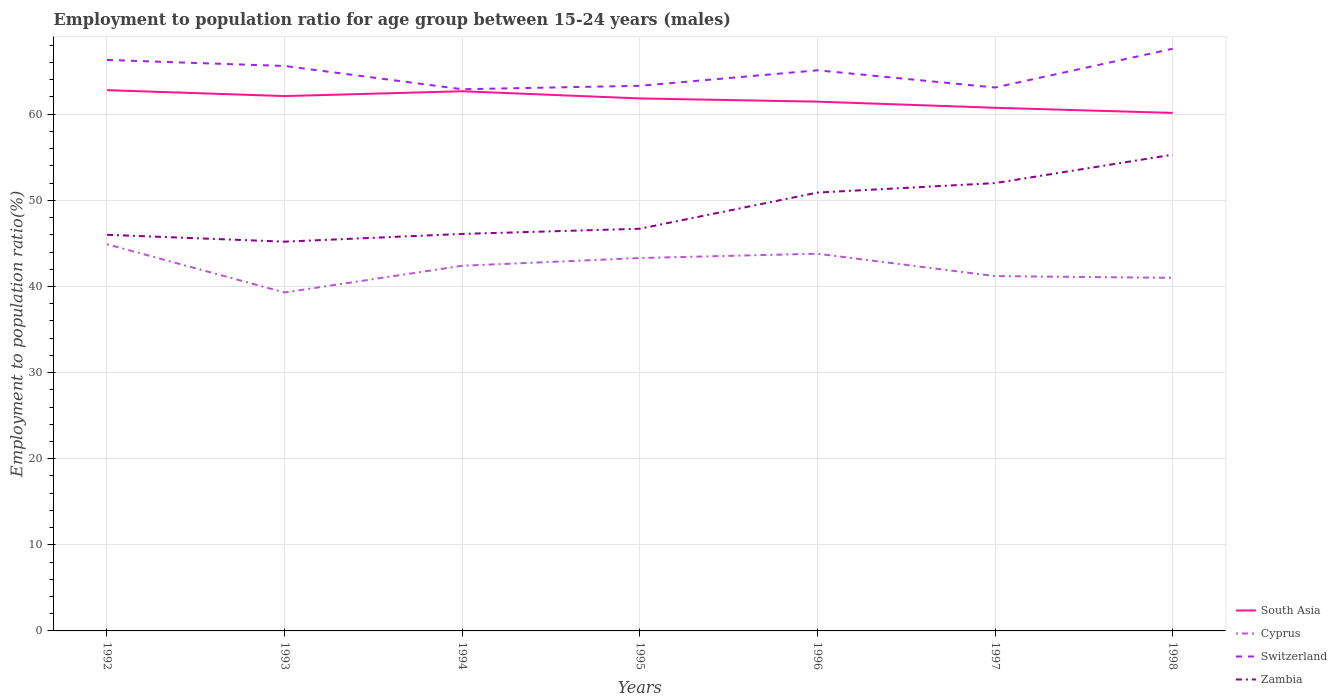Is the number of lines equal to the number of legend labels?
Provide a succinct answer. Yes. Across all years, what is the maximum employment to population ratio in Switzerland?
Give a very brief answer. 62.9. In which year was the employment to population ratio in Switzerland maximum?
Provide a short and direct response. 1994. What is the total employment to population ratio in Switzerland in the graph?
Keep it short and to the point. 2.3. What is the difference between the highest and the second highest employment to population ratio in Switzerland?
Your response must be concise. 4.7. What is the difference between the highest and the lowest employment to population ratio in Switzerland?
Give a very brief answer. 4. Does the graph contain grids?
Provide a succinct answer. Yes. How are the legend labels stacked?
Your answer should be very brief. Vertical. What is the title of the graph?
Your answer should be compact. Employment to population ratio for age group between 15-24 years (males). What is the label or title of the X-axis?
Provide a succinct answer. Years. What is the Employment to population ratio(%) in South Asia in 1992?
Provide a short and direct response. 62.79. What is the Employment to population ratio(%) in Cyprus in 1992?
Offer a terse response. 44.9. What is the Employment to population ratio(%) of Switzerland in 1992?
Keep it short and to the point. 66.3. What is the Employment to population ratio(%) of South Asia in 1993?
Offer a very short reply. 62.11. What is the Employment to population ratio(%) in Cyprus in 1993?
Offer a very short reply. 39.3. What is the Employment to population ratio(%) in Switzerland in 1993?
Provide a short and direct response. 65.6. What is the Employment to population ratio(%) of Zambia in 1993?
Give a very brief answer. 45.2. What is the Employment to population ratio(%) in South Asia in 1994?
Give a very brief answer. 62.67. What is the Employment to population ratio(%) in Cyprus in 1994?
Make the answer very short. 42.4. What is the Employment to population ratio(%) in Switzerland in 1994?
Your answer should be compact. 62.9. What is the Employment to population ratio(%) of Zambia in 1994?
Your response must be concise. 46.1. What is the Employment to population ratio(%) in South Asia in 1995?
Provide a succinct answer. 61.83. What is the Employment to population ratio(%) of Cyprus in 1995?
Make the answer very short. 43.3. What is the Employment to population ratio(%) of Switzerland in 1995?
Keep it short and to the point. 63.3. What is the Employment to population ratio(%) of Zambia in 1995?
Your answer should be very brief. 46.7. What is the Employment to population ratio(%) of South Asia in 1996?
Your answer should be very brief. 61.46. What is the Employment to population ratio(%) in Cyprus in 1996?
Your response must be concise. 43.8. What is the Employment to population ratio(%) in Switzerland in 1996?
Offer a very short reply. 65.1. What is the Employment to population ratio(%) in Zambia in 1996?
Provide a short and direct response. 50.9. What is the Employment to population ratio(%) of South Asia in 1997?
Give a very brief answer. 60.75. What is the Employment to population ratio(%) in Cyprus in 1997?
Your response must be concise. 41.2. What is the Employment to population ratio(%) in Switzerland in 1997?
Offer a terse response. 63.1. What is the Employment to population ratio(%) in South Asia in 1998?
Make the answer very short. 60.15. What is the Employment to population ratio(%) of Cyprus in 1998?
Make the answer very short. 41. What is the Employment to population ratio(%) in Switzerland in 1998?
Offer a very short reply. 67.6. What is the Employment to population ratio(%) in Zambia in 1998?
Make the answer very short. 55.3. Across all years, what is the maximum Employment to population ratio(%) in South Asia?
Provide a succinct answer. 62.79. Across all years, what is the maximum Employment to population ratio(%) in Cyprus?
Provide a succinct answer. 44.9. Across all years, what is the maximum Employment to population ratio(%) of Switzerland?
Your answer should be very brief. 67.6. Across all years, what is the maximum Employment to population ratio(%) of Zambia?
Give a very brief answer. 55.3. Across all years, what is the minimum Employment to population ratio(%) of South Asia?
Ensure brevity in your answer.  60.15. Across all years, what is the minimum Employment to population ratio(%) of Cyprus?
Your answer should be compact. 39.3. Across all years, what is the minimum Employment to population ratio(%) in Switzerland?
Make the answer very short. 62.9. Across all years, what is the minimum Employment to population ratio(%) of Zambia?
Your answer should be very brief. 45.2. What is the total Employment to population ratio(%) in South Asia in the graph?
Offer a very short reply. 431.75. What is the total Employment to population ratio(%) of Cyprus in the graph?
Provide a succinct answer. 295.9. What is the total Employment to population ratio(%) in Switzerland in the graph?
Your answer should be very brief. 453.9. What is the total Employment to population ratio(%) in Zambia in the graph?
Your response must be concise. 342.2. What is the difference between the Employment to population ratio(%) of South Asia in 1992 and that in 1993?
Keep it short and to the point. 0.69. What is the difference between the Employment to population ratio(%) of Cyprus in 1992 and that in 1993?
Make the answer very short. 5.6. What is the difference between the Employment to population ratio(%) in Zambia in 1992 and that in 1993?
Provide a succinct answer. 0.8. What is the difference between the Employment to population ratio(%) in South Asia in 1992 and that in 1994?
Offer a terse response. 0.13. What is the difference between the Employment to population ratio(%) in South Asia in 1992 and that in 1995?
Provide a succinct answer. 0.96. What is the difference between the Employment to population ratio(%) of Cyprus in 1992 and that in 1995?
Make the answer very short. 1.6. What is the difference between the Employment to population ratio(%) in South Asia in 1992 and that in 1996?
Provide a short and direct response. 1.33. What is the difference between the Employment to population ratio(%) of Zambia in 1992 and that in 1996?
Offer a very short reply. -4.9. What is the difference between the Employment to population ratio(%) of South Asia in 1992 and that in 1997?
Ensure brevity in your answer.  2.05. What is the difference between the Employment to population ratio(%) in Cyprus in 1992 and that in 1997?
Your answer should be compact. 3.7. What is the difference between the Employment to population ratio(%) in Switzerland in 1992 and that in 1997?
Offer a terse response. 3.2. What is the difference between the Employment to population ratio(%) in Zambia in 1992 and that in 1997?
Your answer should be very brief. -6. What is the difference between the Employment to population ratio(%) of South Asia in 1992 and that in 1998?
Offer a terse response. 2.65. What is the difference between the Employment to population ratio(%) in Switzerland in 1992 and that in 1998?
Offer a very short reply. -1.3. What is the difference between the Employment to population ratio(%) in South Asia in 1993 and that in 1994?
Keep it short and to the point. -0.56. What is the difference between the Employment to population ratio(%) of Cyprus in 1993 and that in 1994?
Make the answer very short. -3.1. What is the difference between the Employment to population ratio(%) in Switzerland in 1993 and that in 1994?
Provide a succinct answer. 2.7. What is the difference between the Employment to population ratio(%) in Zambia in 1993 and that in 1994?
Offer a terse response. -0.9. What is the difference between the Employment to population ratio(%) in South Asia in 1993 and that in 1995?
Your answer should be very brief. 0.27. What is the difference between the Employment to population ratio(%) of South Asia in 1993 and that in 1996?
Your answer should be compact. 0.65. What is the difference between the Employment to population ratio(%) of South Asia in 1993 and that in 1997?
Offer a very short reply. 1.36. What is the difference between the Employment to population ratio(%) of Cyprus in 1993 and that in 1997?
Give a very brief answer. -1.9. What is the difference between the Employment to population ratio(%) of Zambia in 1993 and that in 1997?
Ensure brevity in your answer.  -6.8. What is the difference between the Employment to population ratio(%) of South Asia in 1993 and that in 1998?
Your answer should be very brief. 1.96. What is the difference between the Employment to population ratio(%) in Cyprus in 1993 and that in 1998?
Provide a short and direct response. -1.7. What is the difference between the Employment to population ratio(%) of South Asia in 1994 and that in 1995?
Offer a terse response. 0.84. What is the difference between the Employment to population ratio(%) in South Asia in 1994 and that in 1996?
Provide a short and direct response. 1.21. What is the difference between the Employment to population ratio(%) of Zambia in 1994 and that in 1996?
Your answer should be very brief. -4.8. What is the difference between the Employment to population ratio(%) of South Asia in 1994 and that in 1997?
Give a very brief answer. 1.92. What is the difference between the Employment to population ratio(%) of Cyprus in 1994 and that in 1997?
Your response must be concise. 1.2. What is the difference between the Employment to population ratio(%) of Switzerland in 1994 and that in 1997?
Offer a terse response. -0.2. What is the difference between the Employment to population ratio(%) in South Asia in 1994 and that in 1998?
Ensure brevity in your answer.  2.52. What is the difference between the Employment to population ratio(%) in Zambia in 1994 and that in 1998?
Your answer should be compact. -9.2. What is the difference between the Employment to population ratio(%) of South Asia in 1995 and that in 1996?
Your answer should be very brief. 0.37. What is the difference between the Employment to population ratio(%) in Switzerland in 1995 and that in 1996?
Keep it short and to the point. -1.8. What is the difference between the Employment to population ratio(%) in Zambia in 1995 and that in 1996?
Give a very brief answer. -4.2. What is the difference between the Employment to population ratio(%) in South Asia in 1995 and that in 1997?
Provide a short and direct response. 1.08. What is the difference between the Employment to population ratio(%) of Cyprus in 1995 and that in 1997?
Give a very brief answer. 2.1. What is the difference between the Employment to population ratio(%) in Switzerland in 1995 and that in 1997?
Offer a terse response. 0.2. What is the difference between the Employment to population ratio(%) of Zambia in 1995 and that in 1997?
Provide a short and direct response. -5.3. What is the difference between the Employment to population ratio(%) in South Asia in 1995 and that in 1998?
Your response must be concise. 1.68. What is the difference between the Employment to population ratio(%) in Switzerland in 1995 and that in 1998?
Ensure brevity in your answer.  -4.3. What is the difference between the Employment to population ratio(%) of Zambia in 1995 and that in 1998?
Keep it short and to the point. -8.6. What is the difference between the Employment to population ratio(%) of South Asia in 1996 and that in 1997?
Make the answer very short. 0.71. What is the difference between the Employment to population ratio(%) of Cyprus in 1996 and that in 1997?
Make the answer very short. 2.6. What is the difference between the Employment to population ratio(%) of Zambia in 1996 and that in 1997?
Your answer should be compact. -1.1. What is the difference between the Employment to population ratio(%) of South Asia in 1996 and that in 1998?
Keep it short and to the point. 1.31. What is the difference between the Employment to population ratio(%) in Switzerland in 1996 and that in 1998?
Your response must be concise. -2.5. What is the difference between the Employment to population ratio(%) in Zambia in 1996 and that in 1998?
Offer a very short reply. -4.4. What is the difference between the Employment to population ratio(%) in South Asia in 1997 and that in 1998?
Provide a succinct answer. 0.6. What is the difference between the Employment to population ratio(%) of Switzerland in 1997 and that in 1998?
Provide a short and direct response. -4.5. What is the difference between the Employment to population ratio(%) in South Asia in 1992 and the Employment to population ratio(%) in Cyprus in 1993?
Make the answer very short. 23.49. What is the difference between the Employment to population ratio(%) in South Asia in 1992 and the Employment to population ratio(%) in Switzerland in 1993?
Offer a very short reply. -2.81. What is the difference between the Employment to population ratio(%) of South Asia in 1992 and the Employment to population ratio(%) of Zambia in 1993?
Your answer should be very brief. 17.59. What is the difference between the Employment to population ratio(%) of Cyprus in 1992 and the Employment to population ratio(%) of Switzerland in 1993?
Give a very brief answer. -20.7. What is the difference between the Employment to population ratio(%) of Switzerland in 1992 and the Employment to population ratio(%) of Zambia in 1993?
Offer a very short reply. 21.1. What is the difference between the Employment to population ratio(%) of South Asia in 1992 and the Employment to population ratio(%) of Cyprus in 1994?
Provide a succinct answer. 20.39. What is the difference between the Employment to population ratio(%) of South Asia in 1992 and the Employment to population ratio(%) of Switzerland in 1994?
Make the answer very short. -0.11. What is the difference between the Employment to population ratio(%) in South Asia in 1992 and the Employment to population ratio(%) in Zambia in 1994?
Your response must be concise. 16.69. What is the difference between the Employment to population ratio(%) of Cyprus in 1992 and the Employment to population ratio(%) of Switzerland in 1994?
Make the answer very short. -18. What is the difference between the Employment to population ratio(%) in Switzerland in 1992 and the Employment to population ratio(%) in Zambia in 1994?
Offer a very short reply. 20.2. What is the difference between the Employment to population ratio(%) in South Asia in 1992 and the Employment to population ratio(%) in Cyprus in 1995?
Your answer should be compact. 19.49. What is the difference between the Employment to population ratio(%) of South Asia in 1992 and the Employment to population ratio(%) of Switzerland in 1995?
Provide a short and direct response. -0.51. What is the difference between the Employment to population ratio(%) in South Asia in 1992 and the Employment to population ratio(%) in Zambia in 1995?
Offer a terse response. 16.09. What is the difference between the Employment to population ratio(%) of Cyprus in 1992 and the Employment to population ratio(%) of Switzerland in 1995?
Provide a short and direct response. -18.4. What is the difference between the Employment to population ratio(%) in Switzerland in 1992 and the Employment to population ratio(%) in Zambia in 1995?
Provide a short and direct response. 19.6. What is the difference between the Employment to population ratio(%) of South Asia in 1992 and the Employment to population ratio(%) of Cyprus in 1996?
Give a very brief answer. 18.99. What is the difference between the Employment to population ratio(%) in South Asia in 1992 and the Employment to population ratio(%) in Switzerland in 1996?
Your response must be concise. -2.31. What is the difference between the Employment to population ratio(%) of South Asia in 1992 and the Employment to population ratio(%) of Zambia in 1996?
Give a very brief answer. 11.89. What is the difference between the Employment to population ratio(%) of Cyprus in 1992 and the Employment to population ratio(%) of Switzerland in 1996?
Keep it short and to the point. -20.2. What is the difference between the Employment to population ratio(%) of South Asia in 1992 and the Employment to population ratio(%) of Cyprus in 1997?
Provide a short and direct response. 21.59. What is the difference between the Employment to population ratio(%) in South Asia in 1992 and the Employment to population ratio(%) in Switzerland in 1997?
Ensure brevity in your answer.  -0.31. What is the difference between the Employment to population ratio(%) of South Asia in 1992 and the Employment to population ratio(%) of Zambia in 1997?
Provide a succinct answer. 10.79. What is the difference between the Employment to population ratio(%) in Cyprus in 1992 and the Employment to population ratio(%) in Switzerland in 1997?
Your answer should be very brief. -18.2. What is the difference between the Employment to population ratio(%) in Cyprus in 1992 and the Employment to population ratio(%) in Zambia in 1997?
Provide a succinct answer. -7.1. What is the difference between the Employment to population ratio(%) of South Asia in 1992 and the Employment to population ratio(%) of Cyprus in 1998?
Your response must be concise. 21.79. What is the difference between the Employment to population ratio(%) of South Asia in 1992 and the Employment to population ratio(%) of Switzerland in 1998?
Ensure brevity in your answer.  -4.81. What is the difference between the Employment to population ratio(%) in South Asia in 1992 and the Employment to population ratio(%) in Zambia in 1998?
Offer a very short reply. 7.49. What is the difference between the Employment to population ratio(%) in Cyprus in 1992 and the Employment to population ratio(%) in Switzerland in 1998?
Give a very brief answer. -22.7. What is the difference between the Employment to population ratio(%) in Cyprus in 1992 and the Employment to population ratio(%) in Zambia in 1998?
Provide a succinct answer. -10.4. What is the difference between the Employment to population ratio(%) in Switzerland in 1992 and the Employment to population ratio(%) in Zambia in 1998?
Keep it short and to the point. 11. What is the difference between the Employment to population ratio(%) in South Asia in 1993 and the Employment to population ratio(%) in Cyprus in 1994?
Your answer should be compact. 19.71. What is the difference between the Employment to population ratio(%) in South Asia in 1993 and the Employment to population ratio(%) in Switzerland in 1994?
Your response must be concise. -0.79. What is the difference between the Employment to population ratio(%) of South Asia in 1993 and the Employment to population ratio(%) of Zambia in 1994?
Provide a short and direct response. 16.01. What is the difference between the Employment to population ratio(%) of Cyprus in 1993 and the Employment to population ratio(%) of Switzerland in 1994?
Offer a terse response. -23.6. What is the difference between the Employment to population ratio(%) of South Asia in 1993 and the Employment to population ratio(%) of Cyprus in 1995?
Provide a succinct answer. 18.81. What is the difference between the Employment to population ratio(%) in South Asia in 1993 and the Employment to population ratio(%) in Switzerland in 1995?
Make the answer very short. -1.19. What is the difference between the Employment to population ratio(%) in South Asia in 1993 and the Employment to population ratio(%) in Zambia in 1995?
Make the answer very short. 15.41. What is the difference between the Employment to population ratio(%) in Cyprus in 1993 and the Employment to population ratio(%) in Zambia in 1995?
Provide a short and direct response. -7.4. What is the difference between the Employment to population ratio(%) of South Asia in 1993 and the Employment to population ratio(%) of Cyprus in 1996?
Your answer should be very brief. 18.31. What is the difference between the Employment to population ratio(%) in South Asia in 1993 and the Employment to population ratio(%) in Switzerland in 1996?
Your response must be concise. -2.99. What is the difference between the Employment to population ratio(%) of South Asia in 1993 and the Employment to population ratio(%) of Zambia in 1996?
Provide a succinct answer. 11.21. What is the difference between the Employment to population ratio(%) of Cyprus in 1993 and the Employment to population ratio(%) of Switzerland in 1996?
Give a very brief answer. -25.8. What is the difference between the Employment to population ratio(%) of Cyprus in 1993 and the Employment to population ratio(%) of Zambia in 1996?
Provide a succinct answer. -11.6. What is the difference between the Employment to population ratio(%) in South Asia in 1993 and the Employment to population ratio(%) in Cyprus in 1997?
Provide a succinct answer. 20.91. What is the difference between the Employment to population ratio(%) in South Asia in 1993 and the Employment to population ratio(%) in Switzerland in 1997?
Provide a short and direct response. -0.99. What is the difference between the Employment to population ratio(%) in South Asia in 1993 and the Employment to population ratio(%) in Zambia in 1997?
Provide a succinct answer. 10.11. What is the difference between the Employment to population ratio(%) in Cyprus in 1993 and the Employment to population ratio(%) in Switzerland in 1997?
Your answer should be very brief. -23.8. What is the difference between the Employment to population ratio(%) in Switzerland in 1993 and the Employment to population ratio(%) in Zambia in 1997?
Give a very brief answer. 13.6. What is the difference between the Employment to population ratio(%) in South Asia in 1993 and the Employment to population ratio(%) in Cyprus in 1998?
Your answer should be compact. 21.11. What is the difference between the Employment to population ratio(%) in South Asia in 1993 and the Employment to population ratio(%) in Switzerland in 1998?
Your answer should be compact. -5.49. What is the difference between the Employment to population ratio(%) in South Asia in 1993 and the Employment to population ratio(%) in Zambia in 1998?
Your answer should be very brief. 6.81. What is the difference between the Employment to population ratio(%) of Cyprus in 1993 and the Employment to population ratio(%) of Switzerland in 1998?
Provide a succinct answer. -28.3. What is the difference between the Employment to population ratio(%) in Cyprus in 1993 and the Employment to population ratio(%) in Zambia in 1998?
Provide a short and direct response. -16. What is the difference between the Employment to population ratio(%) in Switzerland in 1993 and the Employment to population ratio(%) in Zambia in 1998?
Keep it short and to the point. 10.3. What is the difference between the Employment to population ratio(%) of South Asia in 1994 and the Employment to population ratio(%) of Cyprus in 1995?
Provide a short and direct response. 19.37. What is the difference between the Employment to population ratio(%) in South Asia in 1994 and the Employment to population ratio(%) in Switzerland in 1995?
Keep it short and to the point. -0.63. What is the difference between the Employment to population ratio(%) of South Asia in 1994 and the Employment to population ratio(%) of Zambia in 1995?
Your answer should be compact. 15.97. What is the difference between the Employment to population ratio(%) in Cyprus in 1994 and the Employment to population ratio(%) in Switzerland in 1995?
Make the answer very short. -20.9. What is the difference between the Employment to population ratio(%) of Switzerland in 1994 and the Employment to population ratio(%) of Zambia in 1995?
Ensure brevity in your answer.  16.2. What is the difference between the Employment to population ratio(%) in South Asia in 1994 and the Employment to population ratio(%) in Cyprus in 1996?
Your answer should be compact. 18.87. What is the difference between the Employment to population ratio(%) of South Asia in 1994 and the Employment to population ratio(%) of Switzerland in 1996?
Provide a succinct answer. -2.43. What is the difference between the Employment to population ratio(%) in South Asia in 1994 and the Employment to population ratio(%) in Zambia in 1996?
Your response must be concise. 11.77. What is the difference between the Employment to population ratio(%) of Cyprus in 1994 and the Employment to population ratio(%) of Switzerland in 1996?
Provide a succinct answer. -22.7. What is the difference between the Employment to population ratio(%) in Switzerland in 1994 and the Employment to population ratio(%) in Zambia in 1996?
Your answer should be compact. 12. What is the difference between the Employment to population ratio(%) in South Asia in 1994 and the Employment to population ratio(%) in Cyprus in 1997?
Your answer should be very brief. 21.47. What is the difference between the Employment to population ratio(%) of South Asia in 1994 and the Employment to population ratio(%) of Switzerland in 1997?
Your response must be concise. -0.43. What is the difference between the Employment to population ratio(%) of South Asia in 1994 and the Employment to population ratio(%) of Zambia in 1997?
Offer a very short reply. 10.67. What is the difference between the Employment to population ratio(%) of Cyprus in 1994 and the Employment to population ratio(%) of Switzerland in 1997?
Give a very brief answer. -20.7. What is the difference between the Employment to population ratio(%) of Switzerland in 1994 and the Employment to population ratio(%) of Zambia in 1997?
Your response must be concise. 10.9. What is the difference between the Employment to population ratio(%) in South Asia in 1994 and the Employment to population ratio(%) in Cyprus in 1998?
Make the answer very short. 21.67. What is the difference between the Employment to population ratio(%) in South Asia in 1994 and the Employment to population ratio(%) in Switzerland in 1998?
Provide a short and direct response. -4.93. What is the difference between the Employment to population ratio(%) of South Asia in 1994 and the Employment to population ratio(%) of Zambia in 1998?
Provide a succinct answer. 7.37. What is the difference between the Employment to population ratio(%) of Cyprus in 1994 and the Employment to population ratio(%) of Switzerland in 1998?
Your response must be concise. -25.2. What is the difference between the Employment to population ratio(%) of Cyprus in 1994 and the Employment to population ratio(%) of Zambia in 1998?
Offer a terse response. -12.9. What is the difference between the Employment to population ratio(%) of South Asia in 1995 and the Employment to population ratio(%) of Cyprus in 1996?
Your answer should be very brief. 18.03. What is the difference between the Employment to population ratio(%) of South Asia in 1995 and the Employment to population ratio(%) of Switzerland in 1996?
Offer a terse response. -3.27. What is the difference between the Employment to population ratio(%) in South Asia in 1995 and the Employment to population ratio(%) in Zambia in 1996?
Make the answer very short. 10.93. What is the difference between the Employment to population ratio(%) in Cyprus in 1995 and the Employment to population ratio(%) in Switzerland in 1996?
Your response must be concise. -21.8. What is the difference between the Employment to population ratio(%) in Switzerland in 1995 and the Employment to population ratio(%) in Zambia in 1996?
Your answer should be compact. 12.4. What is the difference between the Employment to population ratio(%) of South Asia in 1995 and the Employment to population ratio(%) of Cyprus in 1997?
Provide a succinct answer. 20.63. What is the difference between the Employment to population ratio(%) of South Asia in 1995 and the Employment to population ratio(%) of Switzerland in 1997?
Your answer should be compact. -1.27. What is the difference between the Employment to population ratio(%) in South Asia in 1995 and the Employment to population ratio(%) in Zambia in 1997?
Provide a succinct answer. 9.83. What is the difference between the Employment to population ratio(%) in Cyprus in 1995 and the Employment to population ratio(%) in Switzerland in 1997?
Give a very brief answer. -19.8. What is the difference between the Employment to population ratio(%) of Cyprus in 1995 and the Employment to population ratio(%) of Zambia in 1997?
Keep it short and to the point. -8.7. What is the difference between the Employment to population ratio(%) in Switzerland in 1995 and the Employment to population ratio(%) in Zambia in 1997?
Keep it short and to the point. 11.3. What is the difference between the Employment to population ratio(%) in South Asia in 1995 and the Employment to population ratio(%) in Cyprus in 1998?
Make the answer very short. 20.83. What is the difference between the Employment to population ratio(%) in South Asia in 1995 and the Employment to population ratio(%) in Switzerland in 1998?
Keep it short and to the point. -5.77. What is the difference between the Employment to population ratio(%) of South Asia in 1995 and the Employment to population ratio(%) of Zambia in 1998?
Keep it short and to the point. 6.53. What is the difference between the Employment to population ratio(%) of Cyprus in 1995 and the Employment to population ratio(%) of Switzerland in 1998?
Make the answer very short. -24.3. What is the difference between the Employment to population ratio(%) in Switzerland in 1995 and the Employment to population ratio(%) in Zambia in 1998?
Your answer should be very brief. 8. What is the difference between the Employment to population ratio(%) of South Asia in 1996 and the Employment to population ratio(%) of Cyprus in 1997?
Your response must be concise. 20.26. What is the difference between the Employment to population ratio(%) in South Asia in 1996 and the Employment to population ratio(%) in Switzerland in 1997?
Keep it short and to the point. -1.64. What is the difference between the Employment to population ratio(%) in South Asia in 1996 and the Employment to population ratio(%) in Zambia in 1997?
Make the answer very short. 9.46. What is the difference between the Employment to population ratio(%) in Cyprus in 1996 and the Employment to population ratio(%) in Switzerland in 1997?
Provide a short and direct response. -19.3. What is the difference between the Employment to population ratio(%) of Switzerland in 1996 and the Employment to population ratio(%) of Zambia in 1997?
Ensure brevity in your answer.  13.1. What is the difference between the Employment to population ratio(%) in South Asia in 1996 and the Employment to population ratio(%) in Cyprus in 1998?
Offer a terse response. 20.46. What is the difference between the Employment to population ratio(%) in South Asia in 1996 and the Employment to population ratio(%) in Switzerland in 1998?
Provide a succinct answer. -6.14. What is the difference between the Employment to population ratio(%) in South Asia in 1996 and the Employment to population ratio(%) in Zambia in 1998?
Ensure brevity in your answer.  6.16. What is the difference between the Employment to population ratio(%) in Cyprus in 1996 and the Employment to population ratio(%) in Switzerland in 1998?
Give a very brief answer. -23.8. What is the difference between the Employment to population ratio(%) in Switzerland in 1996 and the Employment to population ratio(%) in Zambia in 1998?
Your answer should be compact. 9.8. What is the difference between the Employment to population ratio(%) of South Asia in 1997 and the Employment to population ratio(%) of Cyprus in 1998?
Your response must be concise. 19.75. What is the difference between the Employment to population ratio(%) in South Asia in 1997 and the Employment to population ratio(%) in Switzerland in 1998?
Make the answer very short. -6.85. What is the difference between the Employment to population ratio(%) of South Asia in 1997 and the Employment to population ratio(%) of Zambia in 1998?
Make the answer very short. 5.45. What is the difference between the Employment to population ratio(%) of Cyprus in 1997 and the Employment to population ratio(%) of Switzerland in 1998?
Your answer should be compact. -26.4. What is the difference between the Employment to population ratio(%) in Cyprus in 1997 and the Employment to population ratio(%) in Zambia in 1998?
Your answer should be very brief. -14.1. What is the average Employment to population ratio(%) of South Asia per year?
Offer a terse response. 61.68. What is the average Employment to population ratio(%) in Cyprus per year?
Give a very brief answer. 42.27. What is the average Employment to population ratio(%) of Switzerland per year?
Provide a succinct answer. 64.84. What is the average Employment to population ratio(%) in Zambia per year?
Provide a succinct answer. 48.89. In the year 1992, what is the difference between the Employment to population ratio(%) of South Asia and Employment to population ratio(%) of Cyprus?
Provide a succinct answer. 17.89. In the year 1992, what is the difference between the Employment to population ratio(%) of South Asia and Employment to population ratio(%) of Switzerland?
Your answer should be very brief. -3.51. In the year 1992, what is the difference between the Employment to population ratio(%) in South Asia and Employment to population ratio(%) in Zambia?
Make the answer very short. 16.79. In the year 1992, what is the difference between the Employment to population ratio(%) of Cyprus and Employment to population ratio(%) of Switzerland?
Offer a terse response. -21.4. In the year 1992, what is the difference between the Employment to population ratio(%) of Cyprus and Employment to population ratio(%) of Zambia?
Ensure brevity in your answer.  -1.1. In the year 1992, what is the difference between the Employment to population ratio(%) in Switzerland and Employment to population ratio(%) in Zambia?
Make the answer very short. 20.3. In the year 1993, what is the difference between the Employment to population ratio(%) of South Asia and Employment to population ratio(%) of Cyprus?
Keep it short and to the point. 22.81. In the year 1993, what is the difference between the Employment to population ratio(%) in South Asia and Employment to population ratio(%) in Switzerland?
Make the answer very short. -3.49. In the year 1993, what is the difference between the Employment to population ratio(%) of South Asia and Employment to population ratio(%) of Zambia?
Ensure brevity in your answer.  16.91. In the year 1993, what is the difference between the Employment to population ratio(%) in Cyprus and Employment to population ratio(%) in Switzerland?
Your answer should be compact. -26.3. In the year 1993, what is the difference between the Employment to population ratio(%) in Cyprus and Employment to population ratio(%) in Zambia?
Your answer should be very brief. -5.9. In the year 1993, what is the difference between the Employment to population ratio(%) in Switzerland and Employment to population ratio(%) in Zambia?
Provide a succinct answer. 20.4. In the year 1994, what is the difference between the Employment to population ratio(%) of South Asia and Employment to population ratio(%) of Cyprus?
Provide a succinct answer. 20.27. In the year 1994, what is the difference between the Employment to population ratio(%) of South Asia and Employment to population ratio(%) of Switzerland?
Give a very brief answer. -0.23. In the year 1994, what is the difference between the Employment to population ratio(%) in South Asia and Employment to population ratio(%) in Zambia?
Give a very brief answer. 16.57. In the year 1994, what is the difference between the Employment to population ratio(%) in Cyprus and Employment to population ratio(%) in Switzerland?
Your response must be concise. -20.5. In the year 1994, what is the difference between the Employment to population ratio(%) of Switzerland and Employment to population ratio(%) of Zambia?
Keep it short and to the point. 16.8. In the year 1995, what is the difference between the Employment to population ratio(%) of South Asia and Employment to population ratio(%) of Cyprus?
Your answer should be very brief. 18.53. In the year 1995, what is the difference between the Employment to population ratio(%) in South Asia and Employment to population ratio(%) in Switzerland?
Keep it short and to the point. -1.47. In the year 1995, what is the difference between the Employment to population ratio(%) in South Asia and Employment to population ratio(%) in Zambia?
Your answer should be compact. 15.13. In the year 1995, what is the difference between the Employment to population ratio(%) of Switzerland and Employment to population ratio(%) of Zambia?
Ensure brevity in your answer.  16.6. In the year 1996, what is the difference between the Employment to population ratio(%) in South Asia and Employment to population ratio(%) in Cyprus?
Offer a very short reply. 17.66. In the year 1996, what is the difference between the Employment to population ratio(%) in South Asia and Employment to population ratio(%) in Switzerland?
Give a very brief answer. -3.64. In the year 1996, what is the difference between the Employment to population ratio(%) in South Asia and Employment to population ratio(%) in Zambia?
Provide a succinct answer. 10.56. In the year 1996, what is the difference between the Employment to population ratio(%) in Cyprus and Employment to population ratio(%) in Switzerland?
Provide a short and direct response. -21.3. In the year 1996, what is the difference between the Employment to population ratio(%) of Cyprus and Employment to population ratio(%) of Zambia?
Provide a succinct answer. -7.1. In the year 1997, what is the difference between the Employment to population ratio(%) in South Asia and Employment to population ratio(%) in Cyprus?
Give a very brief answer. 19.55. In the year 1997, what is the difference between the Employment to population ratio(%) in South Asia and Employment to population ratio(%) in Switzerland?
Provide a short and direct response. -2.35. In the year 1997, what is the difference between the Employment to population ratio(%) in South Asia and Employment to population ratio(%) in Zambia?
Keep it short and to the point. 8.75. In the year 1997, what is the difference between the Employment to population ratio(%) in Cyprus and Employment to population ratio(%) in Switzerland?
Offer a very short reply. -21.9. In the year 1998, what is the difference between the Employment to population ratio(%) in South Asia and Employment to population ratio(%) in Cyprus?
Your response must be concise. 19.15. In the year 1998, what is the difference between the Employment to population ratio(%) of South Asia and Employment to population ratio(%) of Switzerland?
Make the answer very short. -7.45. In the year 1998, what is the difference between the Employment to population ratio(%) of South Asia and Employment to population ratio(%) of Zambia?
Your response must be concise. 4.85. In the year 1998, what is the difference between the Employment to population ratio(%) in Cyprus and Employment to population ratio(%) in Switzerland?
Your answer should be very brief. -26.6. In the year 1998, what is the difference between the Employment to population ratio(%) of Cyprus and Employment to population ratio(%) of Zambia?
Provide a short and direct response. -14.3. In the year 1998, what is the difference between the Employment to population ratio(%) of Switzerland and Employment to population ratio(%) of Zambia?
Keep it short and to the point. 12.3. What is the ratio of the Employment to population ratio(%) of South Asia in 1992 to that in 1993?
Provide a short and direct response. 1.01. What is the ratio of the Employment to population ratio(%) in Cyprus in 1992 to that in 1993?
Your answer should be compact. 1.14. What is the ratio of the Employment to population ratio(%) in Switzerland in 1992 to that in 1993?
Ensure brevity in your answer.  1.01. What is the ratio of the Employment to population ratio(%) of Zambia in 1992 to that in 1993?
Make the answer very short. 1.02. What is the ratio of the Employment to population ratio(%) in Cyprus in 1992 to that in 1994?
Your answer should be very brief. 1.06. What is the ratio of the Employment to population ratio(%) of Switzerland in 1992 to that in 1994?
Offer a very short reply. 1.05. What is the ratio of the Employment to population ratio(%) of South Asia in 1992 to that in 1995?
Your response must be concise. 1.02. What is the ratio of the Employment to population ratio(%) in Switzerland in 1992 to that in 1995?
Your answer should be very brief. 1.05. What is the ratio of the Employment to population ratio(%) of Zambia in 1992 to that in 1995?
Give a very brief answer. 0.98. What is the ratio of the Employment to population ratio(%) in South Asia in 1992 to that in 1996?
Provide a succinct answer. 1.02. What is the ratio of the Employment to population ratio(%) of Cyprus in 1992 to that in 1996?
Offer a very short reply. 1.03. What is the ratio of the Employment to population ratio(%) in Switzerland in 1992 to that in 1996?
Provide a short and direct response. 1.02. What is the ratio of the Employment to population ratio(%) of Zambia in 1992 to that in 1996?
Make the answer very short. 0.9. What is the ratio of the Employment to population ratio(%) in South Asia in 1992 to that in 1997?
Your response must be concise. 1.03. What is the ratio of the Employment to population ratio(%) in Cyprus in 1992 to that in 1997?
Provide a short and direct response. 1.09. What is the ratio of the Employment to population ratio(%) in Switzerland in 1992 to that in 1997?
Provide a succinct answer. 1.05. What is the ratio of the Employment to population ratio(%) in Zambia in 1992 to that in 1997?
Your answer should be very brief. 0.88. What is the ratio of the Employment to population ratio(%) in South Asia in 1992 to that in 1998?
Ensure brevity in your answer.  1.04. What is the ratio of the Employment to population ratio(%) of Cyprus in 1992 to that in 1998?
Your answer should be compact. 1.1. What is the ratio of the Employment to population ratio(%) of Switzerland in 1992 to that in 1998?
Provide a short and direct response. 0.98. What is the ratio of the Employment to population ratio(%) in Zambia in 1992 to that in 1998?
Your answer should be very brief. 0.83. What is the ratio of the Employment to population ratio(%) in South Asia in 1993 to that in 1994?
Your response must be concise. 0.99. What is the ratio of the Employment to population ratio(%) in Cyprus in 1993 to that in 1994?
Your response must be concise. 0.93. What is the ratio of the Employment to population ratio(%) of Switzerland in 1993 to that in 1994?
Give a very brief answer. 1.04. What is the ratio of the Employment to population ratio(%) in Zambia in 1993 to that in 1994?
Give a very brief answer. 0.98. What is the ratio of the Employment to population ratio(%) of South Asia in 1993 to that in 1995?
Ensure brevity in your answer.  1. What is the ratio of the Employment to population ratio(%) of Cyprus in 1993 to that in 1995?
Provide a succinct answer. 0.91. What is the ratio of the Employment to population ratio(%) in Switzerland in 1993 to that in 1995?
Offer a very short reply. 1.04. What is the ratio of the Employment to population ratio(%) of Zambia in 1993 to that in 1995?
Offer a terse response. 0.97. What is the ratio of the Employment to population ratio(%) of South Asia in 1993 to that in 1996?
Offer a very short reply. 1.01. What is the ratio of the Employment to population ratio(%) in Cyprus in 1993 to that in 1996?
Your answer should be compact. 0.9. What is the ratio of the Employment to population ratio(%) of Switzerland in 1993 to that in 1996?
Offer a terse response. 1.01. What is the ratio of the Employment to population ratio(%) of Zambia in 1993 to that in 1996?
Your answer should be very brief. 0.89. What is the ratio of the Employment to population ratio(%) in South Asia in 1993 to that in 1997?
Your response must be concise. 1.02. What is the ratio of the Employment to population ratio(%) of Cyprus in 1993 to that in 1997?
Provide a short and direct response. 0.95. What is the ratio of the Employment to population ratio(%) in Switzerland in 1993 to that in 1997?
Your answer should be very brief. 1.04. What is the ratio of the Employment to population ratio(%) of Zambia in 1993 to that in 1997?
Provide a short and direct response. 0.87. What is the ratio of the Employment to population ratio(%) of South Asia in 1993 to that in 1998?
Provide a short and direct response. 1.03. What is the ratio of the Employment to population ratio(%) in Cyprus in 1993 to that in 1998?
Your response must be concise. 0.96. What is the ratio of the Employment to population ratio(%) of Switzerland in 1993 to that in 1998?
Provide a succinct answer. 0.97. What is the ratio of the Employment to population ratio(%) in Zambia in 1993 to that in 1998?
Offer a very short reply. 0.82. What is the ratio of the Employment to population ratio(%) of South Asia in 1994 to that in 1995?
Your response must be concise. 1.01. What is the ratio of the Employment to population ratio(%) of Cyprus in 1994 to that in 1995?
Ensure brevity in your answer.  0.98. What is the ratio of the Employment to population ratio(%) of Switzerland in 1994 to that in 1995?
Keep it short and to the point. 0.99. What is the ratio of the Employment to population ratio(%) in Zambia in 1994 to that in 1995?
Your answer should be compact. 0.99. What is the ratio of the Employment to population ratio(%) of South Asia in 1994 to that in 1996?
Your answer should be very brief. 1.02. What is the ratio of the Employment to population ratio(%) of Switzerland in 1994 to that in 1996?
Provide a succinct answer. 0.97. What is the ratio of the Employment to population ratio(%) of Zambia in 1994 to that in 1996?
Keep it short and to the point. 0.91. What is the ratio of the Employment to population ratio(%) of South Asia in 1994 to that in 1997?
Make the answer very short. 1.03. What is the ratio of the Employment to population ratio(%) of Cyprus in 1994 to that in 1997?
Your answer should be very brief. 1.03. What is the ratio of the Employment to population ratio(%) of Switzerland in 1994 to that in 1997?
Your response must be concise. 1. What is the ratio of the Employment to population ratio(%) in Zambia in 1994 to that in 1997?
Give a very brief answer. 0.89. What is the ratio of the Employment to population ratio(%) of South Asia in 1994 to that in 1998?
Offer a very short reply. 1.04. What is the ratio of the Employment to population ratio(%) of Cyprus in 1994 to that in 1998?
Ensure brevity in your answer.  1.03. What is the ratio of the Employment to population ratio(%) in Switzerland in 1994 to that in 1998?
Ensure brevity in your answer.  0.93. What is the ratio of the Employment to population ratio(%) of Zambia in 1994 to that in 1998?
Provide a succinct answer. 0.83. What is the ratio of the Employment to population ratio(%) of South Asia in 1995 to that in 1996?
Provide a short and direct response. 1.01. What is the ratio of the Employment to population ratio(%) in Switzerland in 1995 to that in 1996?
Provide a short and direct response. 0.97. What is the ratio of the Employment to population ratio(%) in Zambia in 1995 to that in 1996?
Give a very brief answer. 0.92. What is the ratio of the Employment to population ratio(%) of South Asia in 1995 to that in 1997?
Provide a succinct answer. 1.02. What is the ratio of the Employment to population ratio(%) of Cyprus in 1995 to that in 1997?
Your answer should be compact. 1.05. What is the ratio of the Employment to population ratio(%) in Zambia in 1995 to that in 1997?
Your answer should be very brief. 0.9. What is the ratio of the Employment to population ratio(%) of South Asia in 1995 to that in 1998?
Offer a terse response. 1.03. What is the ratio of the Employment to population ratio(%) of Cyprus in 1995 to that in 1998?
Provide a succinct answer. 1.06. What is the ratio of the Employment to population ratio(%) of Switzerland in 1995 to that in 1998?
Your answer should be very brief. 0.94. What is the ratio of the Employment to population ratio(%) of Zambia in 1995 to that in 1998?
Ensure brevity in your answer.  0.84. What is the ratio of the Employment to population ratio(%) in South Asia in 1996 to that in 1997?
Provide a succinct answer. 1.01. What is the ratio of the Employment to population ratio(%) in Cyprus in 1996 to that in 1997?
Provide a succinct answer. 1.06. What is the ratio of the Employment to population ratio(%) in Switzerland in 1996 to that in 1997?
Make the answer very short. 1.03. What is the ratio of the Employment to population ratio(%) of Zambia in 1996 to that in 1997?
Provide a short and direct response. 0.98. What is the ratio of the Employment to population ratio(%) in South Asia in 1996 to that in 1998?
Give a very brief answer. 1.02. What is the ratio of the Employment to population ratio(%) in Cyprus in 1996 to that in 1998?
Ensure brevity in your answer.  1.07. What is the ratio of the Employment to population ratio(%) of Switzerland in 1996 to that in 1998?
Your answer should be compact. 0.96. What is the ratio of the Employment to population ratio(%) of Zambia in 1996 to that in 1998?
Make the answer very short. 0.92. What is the ratio of the Employment to population ratio(%) of South Asia in 1997 to that in 1998?
Your answer should be compact. 1.01. What is the ratio of the Employment to population ratio(%) of Switzerland in 1997 to that in 1998?
Give a very brief answer. 0.93. What is the ratio of the Employment to population ratio(%) in Zambia in 1997 to that in 1998?
Make the answer very short. 0.94. What is the difference between the highest and the second highest Employment to population ratio(%) in South Asia?
Your answer should be compact. 0.13. What is the difference between the highest and the second highest Employment to population ratio(%) of Zambia?
Offer a terse response. 3.3. What is the difference between the highest and the lowest Employment to population ratio(%) in South Asia?
Give a very brief answer. 2.65. What is the difference between the highest and the lowest Employment to population ratio(%) of Switzerland?
Offer a terse response. 4.7. What is the difference between the highest and the lowest Employment to population ratio(%) in Zambia?
Provide a short and direct response. 10.1. 